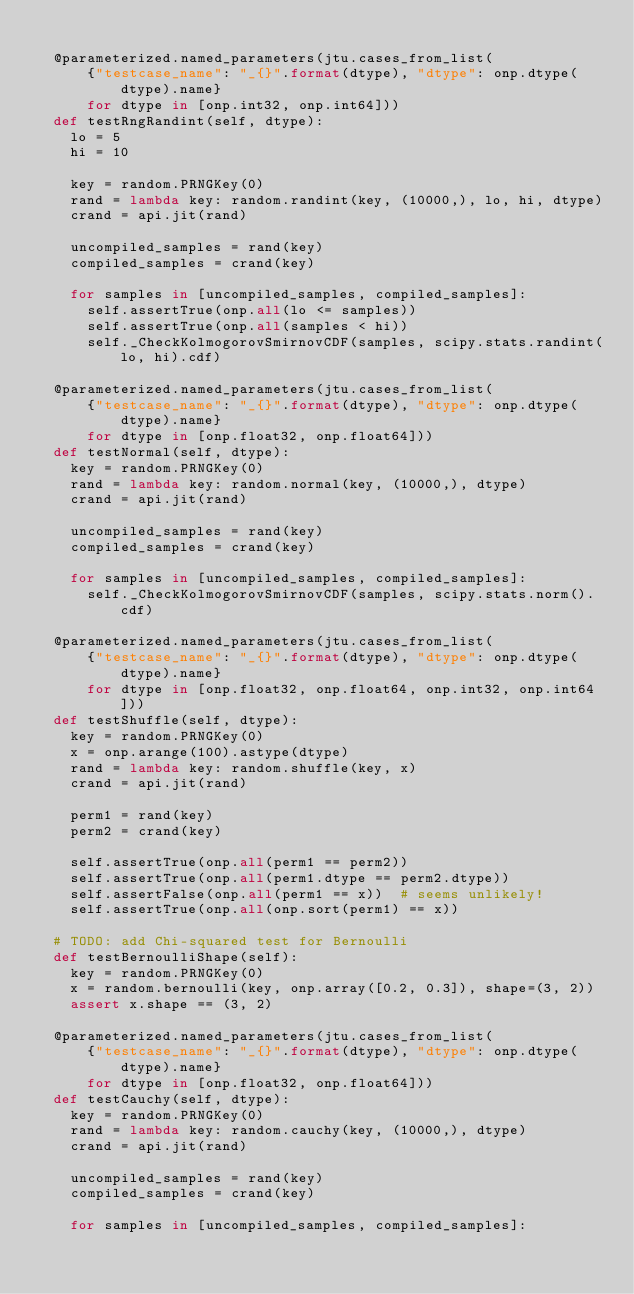Convert code to text. <code><loc_0><loc_0><loc_500><loc_500><_Python_>
  @parameterized.named_parameters(jtu.cases_from_list(
      {"testcase_name": "_{}".format(dtype), "dtype": onp.dtype(dtype).name}
      for dtype in [onp.int32, onp.int64]))
  def testRngRandint(self, dtype):
    lo = 5
    hi = 10

    key = random.PRNGKey(0)
    rand = lambda key: random.randint(key, (10000,), lo, hi, dtype)
    crand = api.jit(rand)

    uncompiled_samples = rand(key)
    compiled_samples = crand(key)

    for samples in [uncompiled_samples, compiled_samples]:
      self.assertTrue(onp.all(lo <= samples))
      self.assertTrue(onp.all(samples < hi))
      self._CheckKolmogorovSmirnovCDF(samples, scipy.stats.randint(lo, hi).cdf)

  @parameterized.named_parameters(jtu.cases_from_list(
      {"testcase_name": "_{}".format(dtype), "dtype": onp.dtype(dtype).name}
      for dtype in [onp.float32, onp.float64]))
  def testNormal(self, dtype):
    key = random.PRNGKey(0)
    rand = lambda key: random.normal(key, (10000,), dtype)
    crand = api.jit(rand)

    uncompiled_samples = rand(key)
    compiled_samples = crand(key)

    for samples in [uncompiled_samples, compiled_samples]:
      self._CheckKolmogorovSmirnovCDF(samples, scipy.stats.norm().cdf)

  @parameterized.named_parameters(jtu.cases_from_list(
      {"testcase_name": "_{}".format(dtype), "dtype": onp.dtype(dtype).name}
      for dtype in [onp.float32, onp.float64, onp.int32, onp.int64]))
  def testShuffle(self, dtype):
    key = random.PRNGKey(0)
    x = onp.arange(100).astype(dtype)
    rand = lambda key: random.shuffle(key, x)
    crand = api.jit(rand)

    perm1 = rand(key)
    perm2 = crand(key)

    self.assertTrue(onp.all(perm1 == perm2))
    self.assertTrue(onp.all(perm1.dtype == perm2.dtype))
    self.assertFalse(onp.all(perm1 == x))  # seems unlikely!
    self.assertTrue(onp.all(onp.sort(perm1) == x))

  # TODO: add Chi-squared test for Bernoulli
  def testBernoulliShape(self):
    key = random.PRNGKey(0)
    x = random.bernoulli(key, onp.array([0.2, 0.3]), shape=(3, 2))
    assert x.shape == (3, 2)

  @parameterized.named_parameters(jtu.cases_from_list(
      {"testcase_name": "_{}".format(dtype), "dtype": onp.dtype(dtype).name}
      for dtype in [onp.float32, onp.float64]))
  def testCauchy(self, dtype):
    key = random.PRNGKey(0)
    rand = lambda key: random.cauchy(key, (10000,), dtype)
    crand = api.jit(rand)

    uncompiled_samples = rand(key)
    compiled_samples = crand(key)

    for samples in [uncompiled_samples, compiled_samples]:</code> 